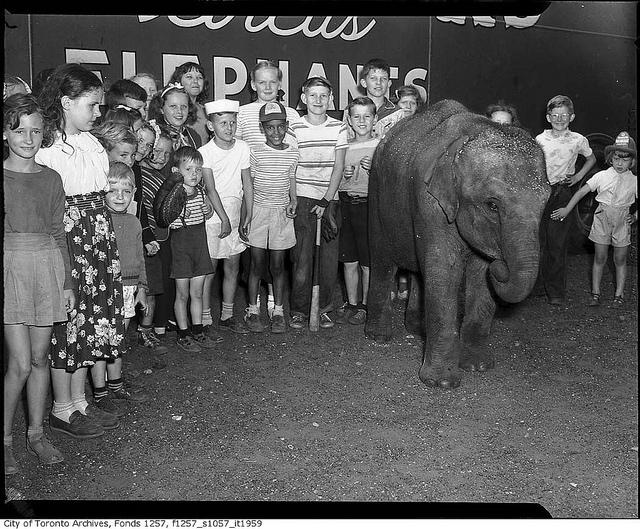What is the elephants trunk doing? Please explain your reasoning. curling. It is pulled up towards his body. 